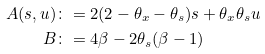Convert formula to latex. <formula><loc_0><loc_0><loc_500><loc_500>A ( s , u ) & \colon = 2 ( 2 - \theta _ { x } - \theta _ { s } ) s + \theta _ { x } \theta _ { s } u \\ B & \colon = 4 \beta - 2 \theta _ { s } ( \beta - 1 )</formula> 